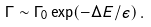<formula> <loc_0><loc_0><loc_500><loc_500>\Gamma \sim \Gamma _ { 0 } \exp ( - \Delta E / \epsilon ) \, .</formula> 